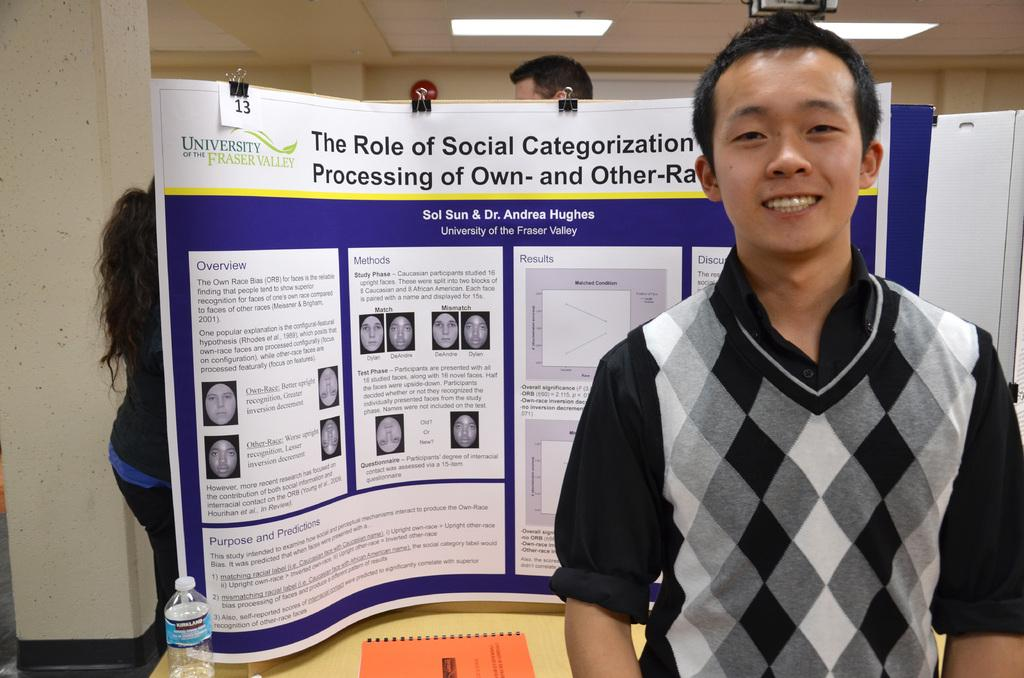<image>
Render a clear and concise summary of the photo. Man presents his thesis at a medical conference 